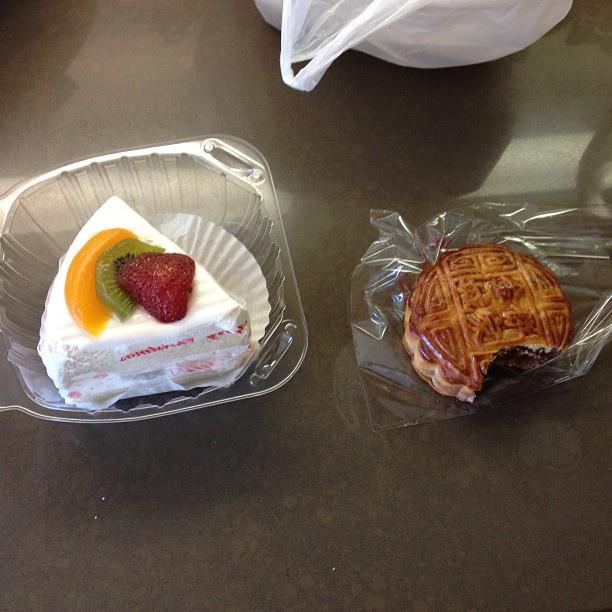Are either of the pastries missing pieces?
Concise answer only. Yes. What color is dominant?
Give a very brief answer. Brown. What has happened to the pastry on the left?
Write a very short answer. Nothing. 